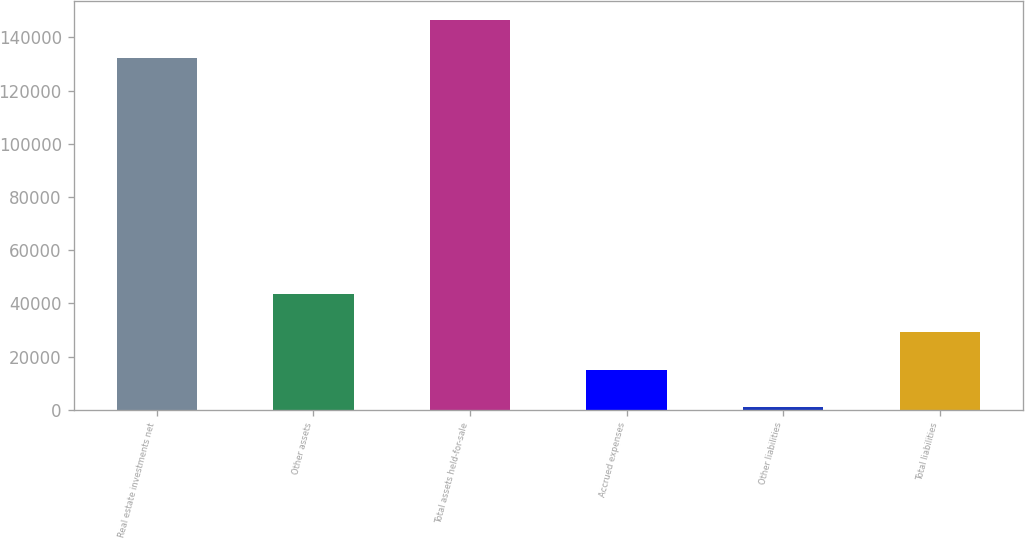Convert chart to OTSL. <chart><loc_0><loc_0><loc_500><loc_500><bar_chart><fcel>Real estate investments net<fcel>Other assets<fcel>Total assets held-for-sale<fcel>Accrued expenses<fcel>Other liabilities<fcel>Total liabilities<nl><fcel>132194<fcel>43411.5<fcel>146328<fcel>15144.5<fcel>1011<fcel>29278<nl></chart> 